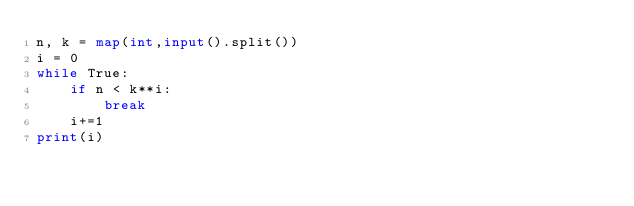<code> <loc_0><loc_0><loc_500><loc_500><_Python_>n, k = map(int,input().split())
i = 0
while True:
    if n < k**i:
        break
    i+=1
print(i)</code> 